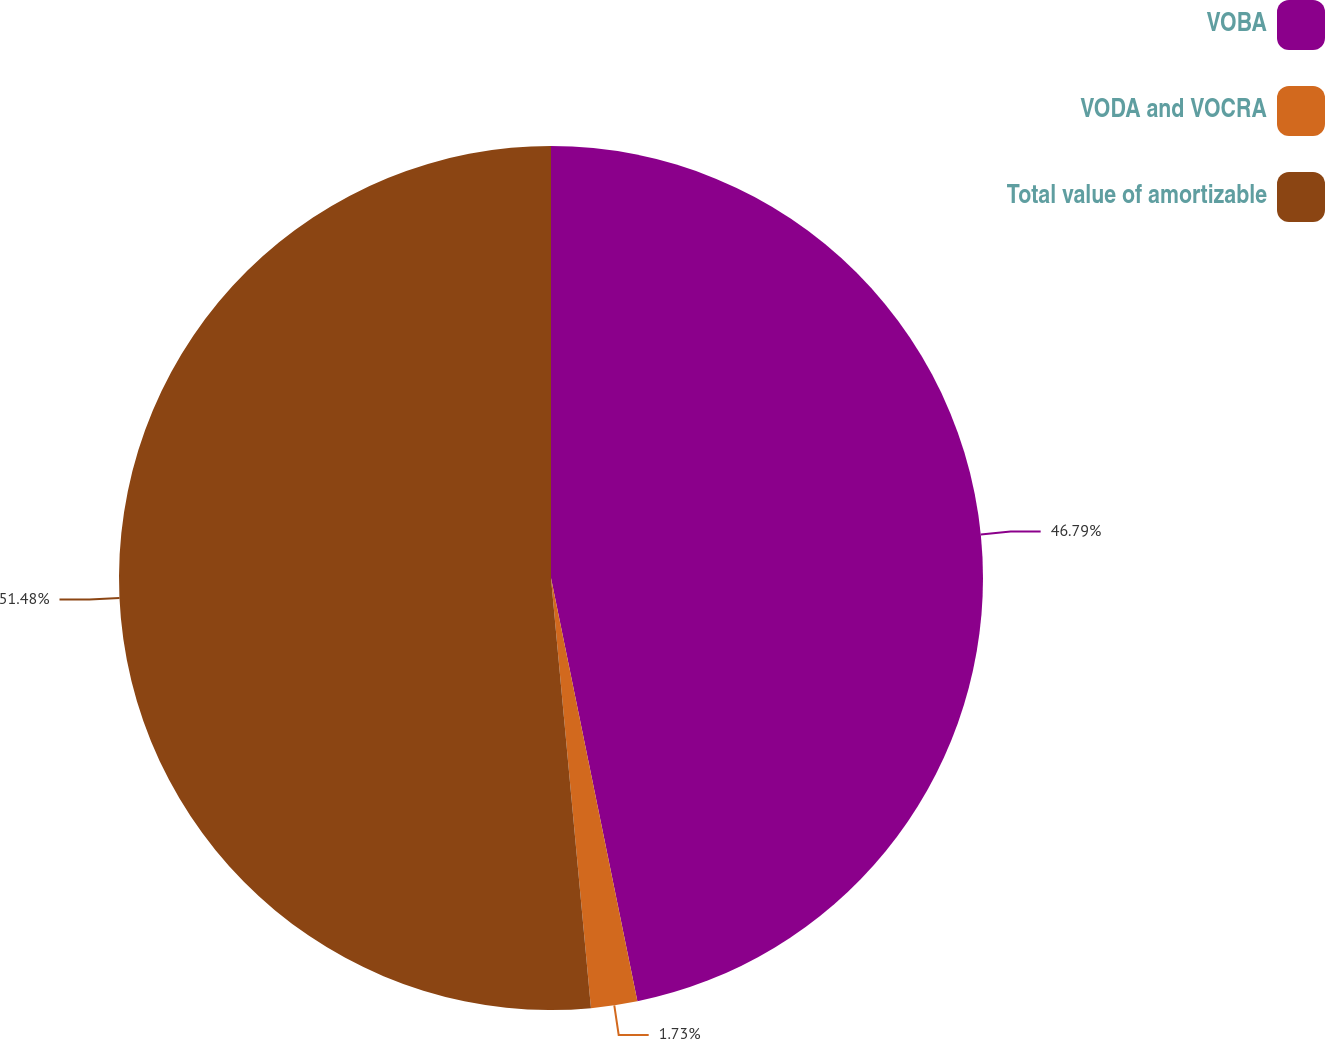<chart> <loc_0><loc_0><loc_500><loc_500><pie_chart><fcel>VOBA<fcel>VODA and VOCRA<fcel>Total value of amortizable<nl><fcel>46.79%<fcel>1.73%<fcel>51.47%<nl></chart> 